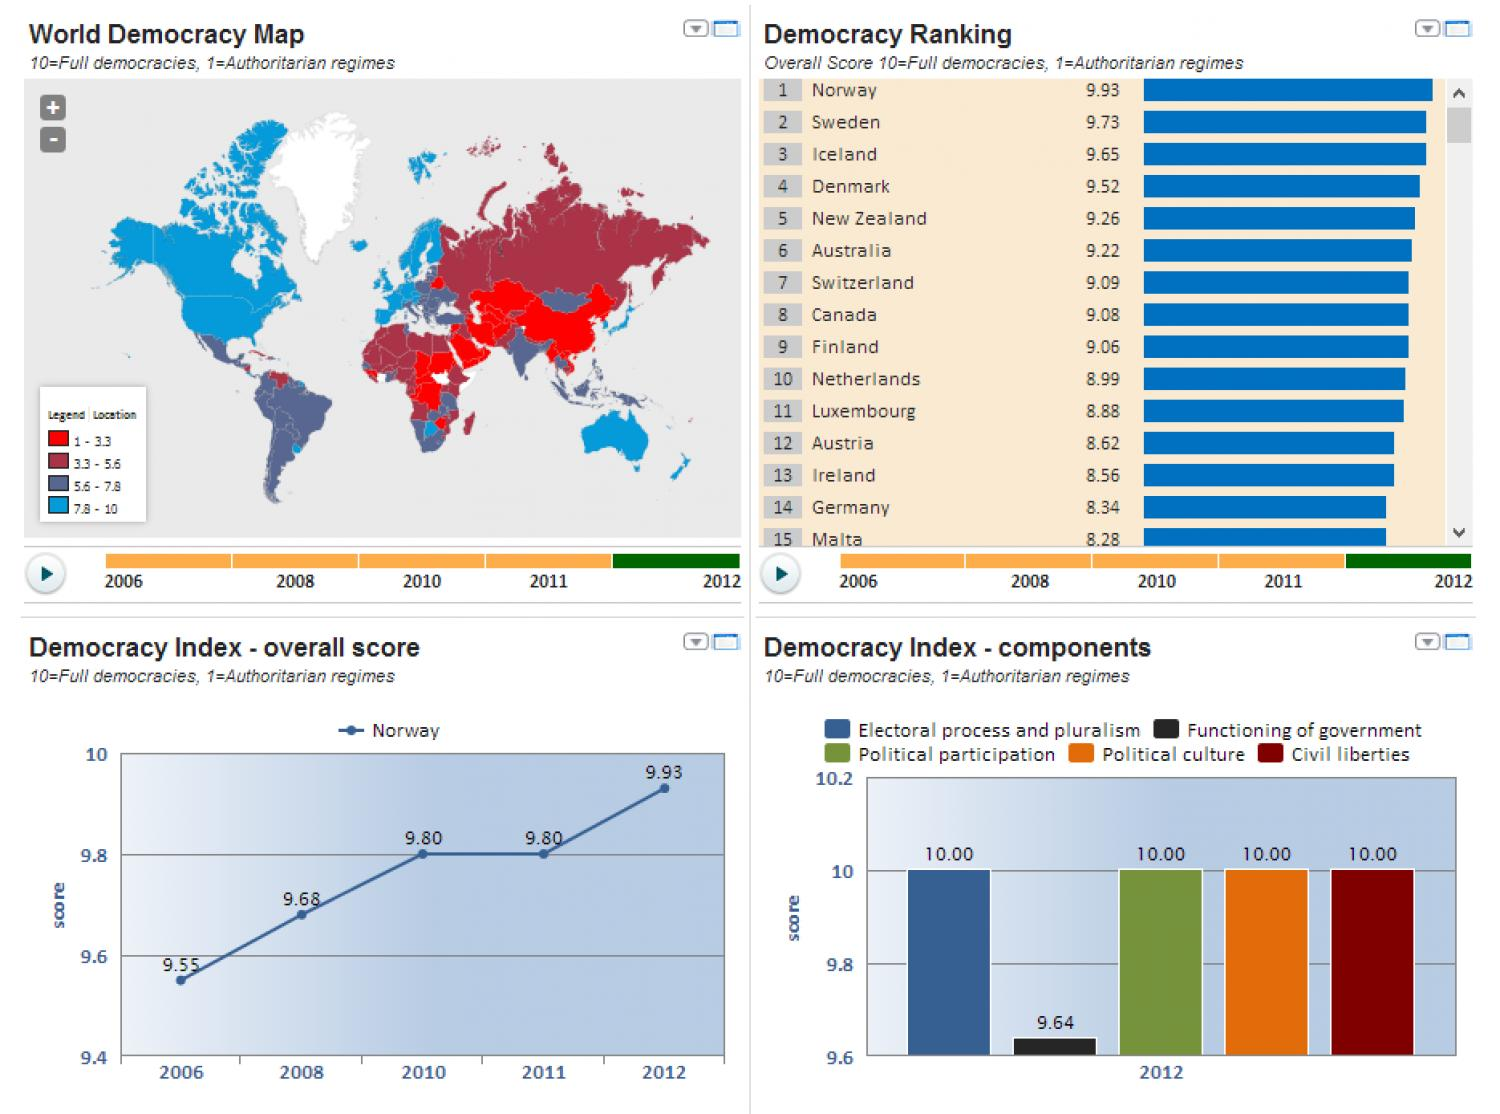Specify some key components in this picture. Iceland was ranked as the third most democratic country in 2012. According to the bar chart, the score for the functioning of the government in 2012 was 9.64 out of 10. According to the bar chart, the score for civil liberties in 2012 was 10. Sweden was ranked as the second most democratic country in 2012. According to the ranking in 2012, the Netherlands was the country with the 10th highest level of democracy. 